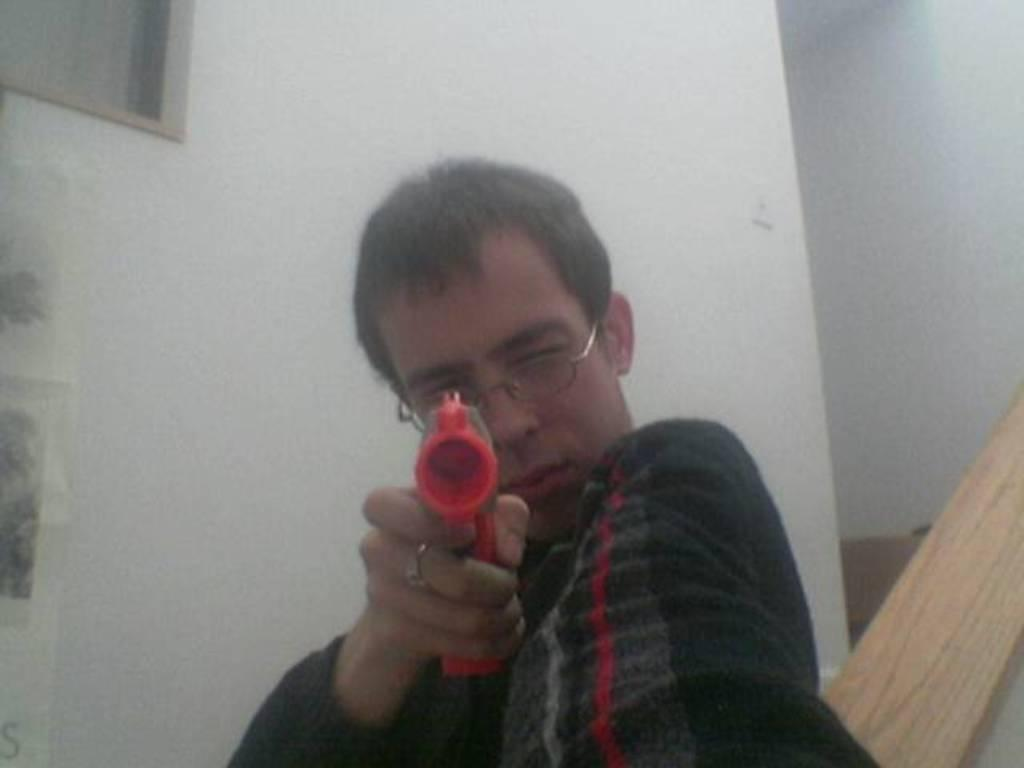Who is present in the image? There is a man in the image. What is the man holding in the image? The man is holding an object. What can be seen in the background of the image? There is a wall in the image. What type of health advice is the man giving to the toad in the image? There is no toad present in the image, and the man is not giving any health advice. 